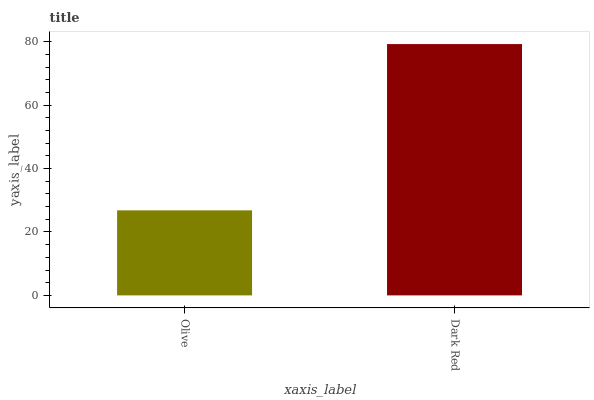Is Olive the minimum?
Answer yes or no. Yes. Is Dark Red the maximum?
Answer yes or no. Yes. Is Dark Red the minimum?
Answer yes or no. No. Is Dark Red greater than Olive?
Answer yes or no. Yes. Is Olive less than Dark Red?
Answer yes or no. Yes. Is Olive greater than Dark Red?
Answer yes or no. No. Is Dark Red less than Olive?
Answer yes or no. No. Is Dark Red the high median?
Answer yes or no. Yes. Is Olive the low median?
Answer yes or no. Yes. Is Olive the high median?
Answer yes or no. No. Is Dark Red the low median?
Answer yes or no. No. 